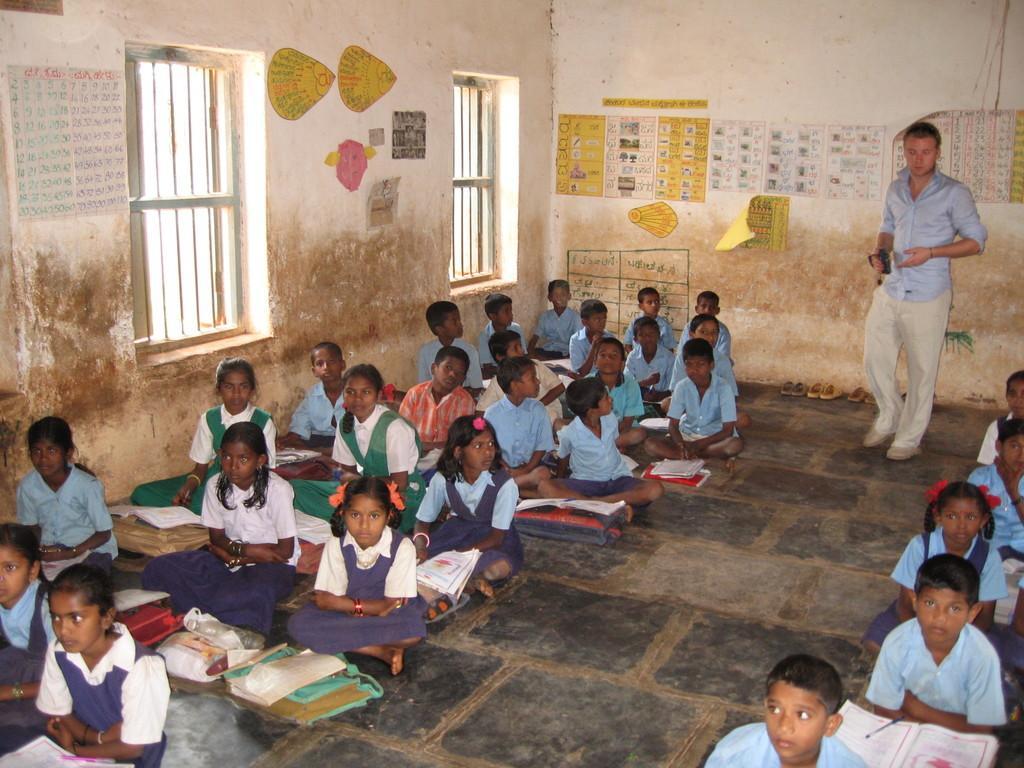How would you summarize this image in a sentence or two? It is a picture of a classroom. In this picture I can see children are sitting on the floor, In-front of them there are bags and books. In the background there are windows, walls, a person and posters. Posters are on the wall. A person is holding an object. In-front of the wall there are footwear's,   